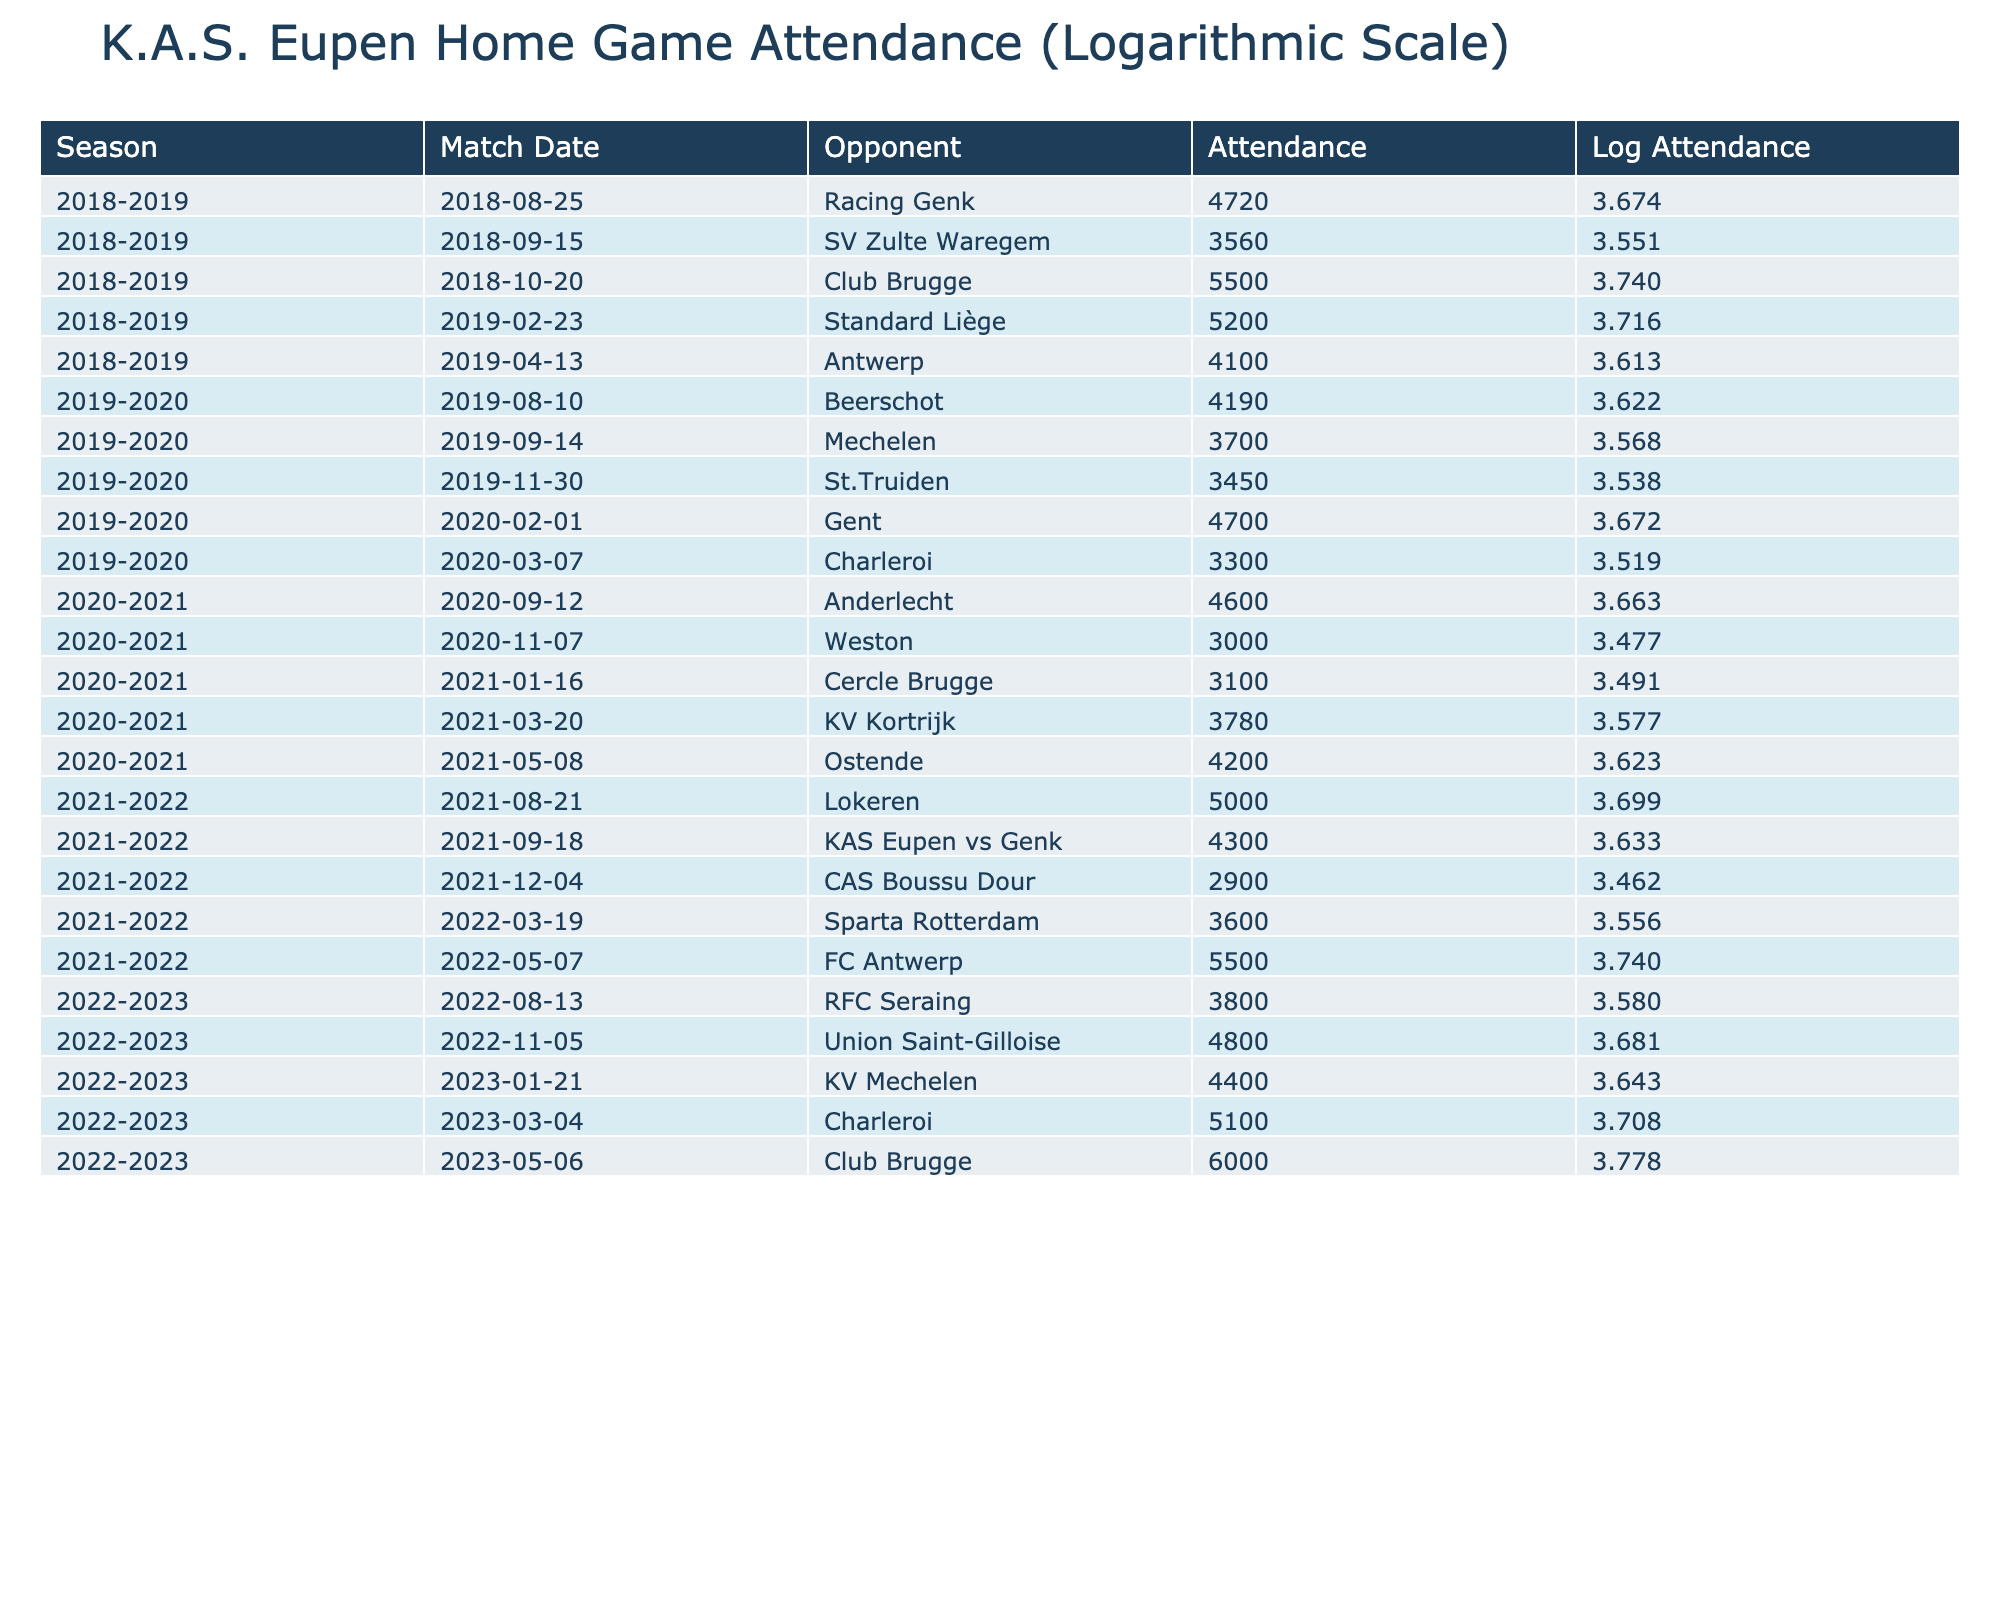What was the highest match attendance for K.A.S. Eupen during the 2022-2023 season? According to the table, the highest attendance during the 2022-2023 season is listed against Club Brugge on 2023-05-06 with an attendance of 6000.
Answer: 6000 In which season did K.A.S. Eupen have the match against Anderlecht, and what was the attendance? The match against Anderlecht is recorded in the 2020-2021 season with a reported attendance of 4600.
Answer: 4600 in the 2020-2021 season What is the average attendance for home matches against Antwerp across all seasons? The table shows two matches against Antwerp with attendances of 4100 in 2018-2019 and 5500 in 2021-2022. The average is calculated as (4100 + 5500) / 2 = 4800.
Answer: 4800 True or false: The attendance during the match against SV Zulte Waregem was higher than 4000. Looking at the attendance for the match against SV Zulte Waregem on 2018-09-15, it shows 3560, which is below 4000. Thus, this statement is false.
Answer: False Which opponent had the lowest attendance in K.A.S. Eupen's home games over the last five seasons? By analyzing the attendees from all the matches, the lowest attendance is noted as 2900 during the match against CAS Boussu Dour on 2021-12-04.
Answer: 2900 against CAS Boussu Dour What is the total attendance for all matches played in the 2019-2020 season? The attendance figures for the 2019-2020 season are: 4190, 3700, 3450, 4700, and 3300. Adding these values (4190 + 3700 + 3450 + 4700 + 3300) gives a total of 19340 for that season.
Answer: 19340 Did K.A.S. Eupen have any matches with an attendance of less than 3000? Reviewing the attendance records in the table, the lowest attendance is 2900, which indicates that yes, there was a match with less than 3000 attendees (against CAS Boussu Dour).
Answer: Yes What was the trend in attendance from the 2018-2019 season to the 2022-2023 season, particularly for the matches against Club Brugge? In the 2018-2019 season, the attendance for the match against Club Brugge was 5500, and in the 2022-2023 season, it rose to 6000. This demonstrates an upward trend in attendance for matches against Club Brugge over those seasons.
Answer: Upward trend What was the log attendance for the match against KV Kortrijk in the 2020-2021 season? The attendance for the match against KV Kortrijk on 2021-03-20 is 3780. The log attendance is calculated using the logarithm: log10(3780) which gives approximately 3.577.
Answer: Approximately 3.577 